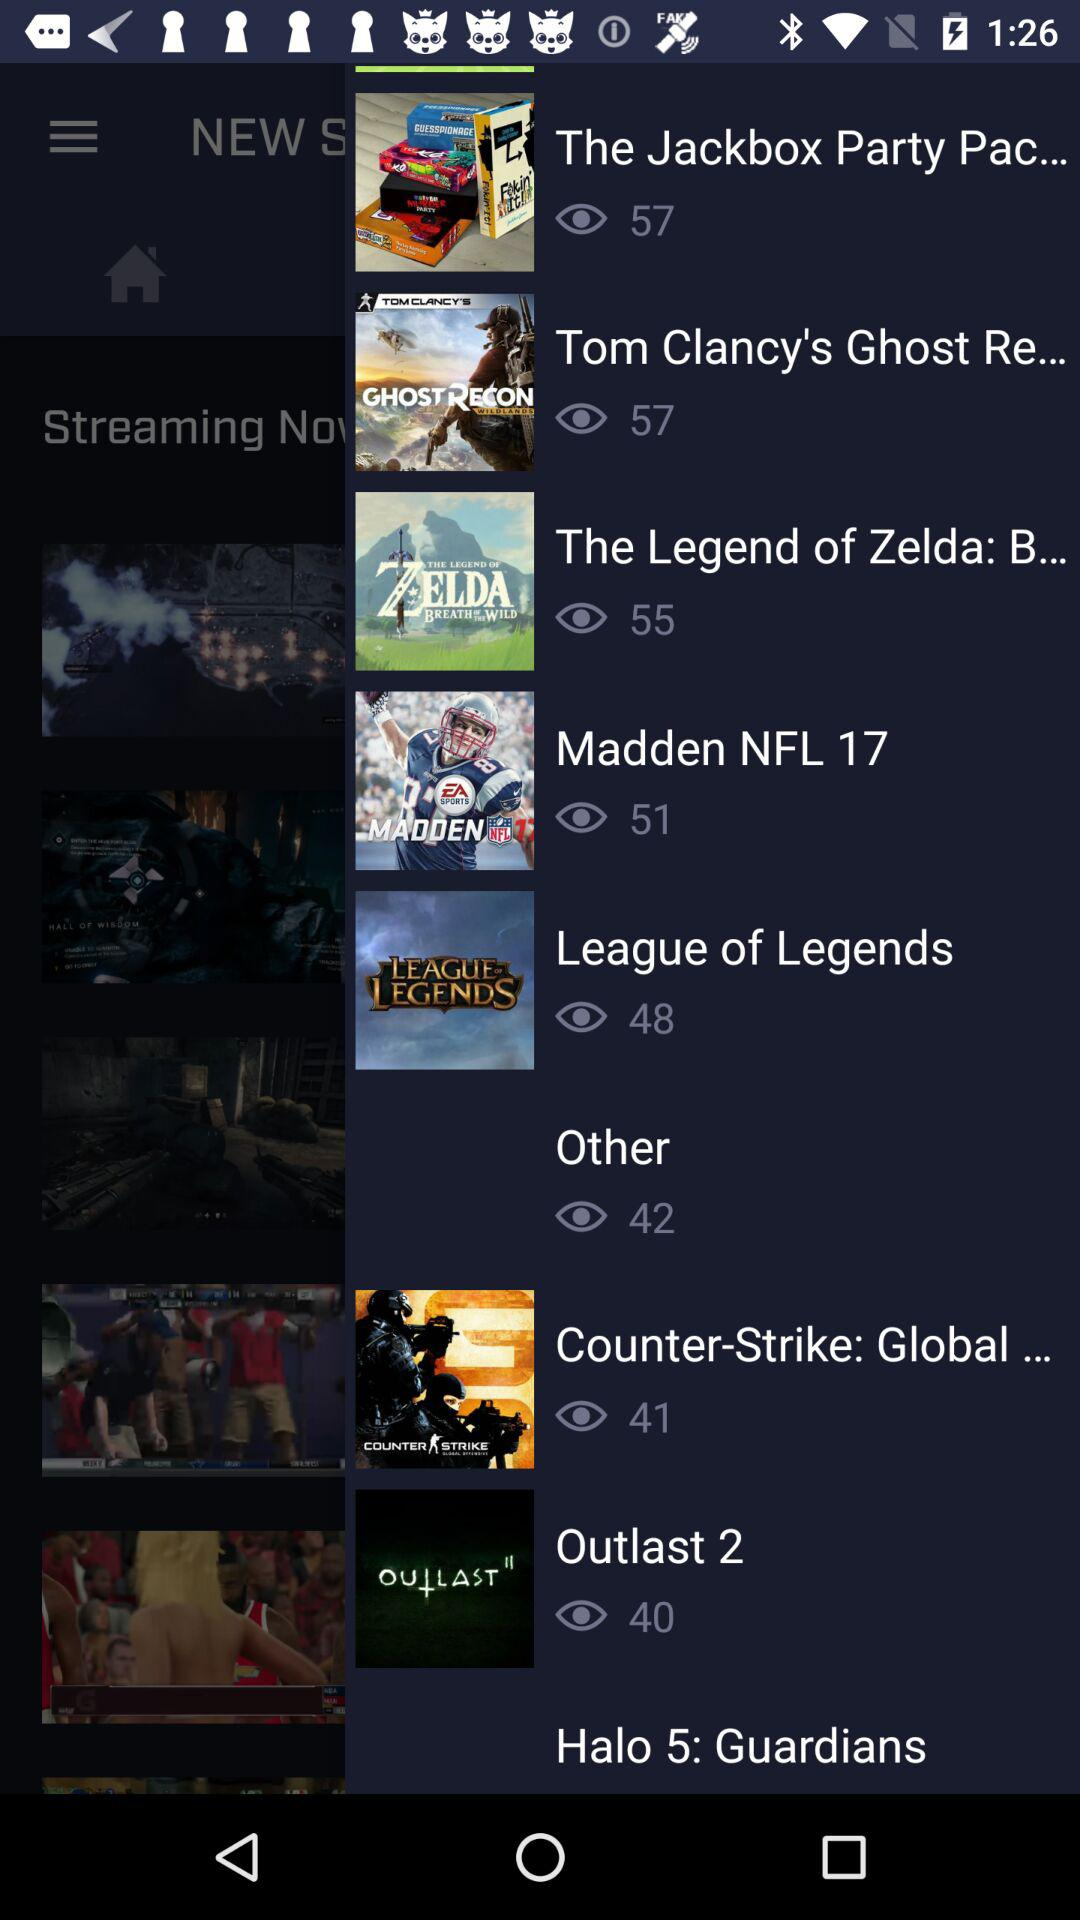On what show are there 40 views? There are 40 views on the show "Outlast 2". 